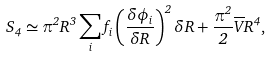<formula> <loc_0><loc_0><loc_500><loc_500>S _ { 4 } \simeq \pi ^ { 2 } R ^ { 3 } \sum _ { i } f _ { i } \left ( \frac { \delta \phi _ { i } } { \delta R } \right ) ^ { 2 } \delta R + \frac { \pi ^ { 2 } } { 2 } \overline { V } R ^ { 4 } ,</formula> 